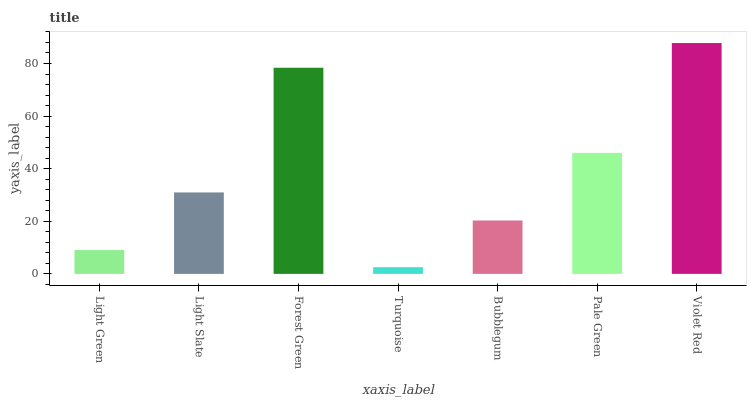Is Turquoise the minimum?
Answer yes or no. Yes. Is Violet Red the maximum?
Answer yes or no. Yes. Is Light Slate the minimum?
Answer yes or no. No. Is Light Slate the maximum?
Answer yes or no. No. Is Light Slate greater than Light Green?
Answer yes or no. Yes. Is Light Green less than Light Slate?
Answer yes or no. Yes. Is Light Green greater than Light Slate?
Answer yes or no. No. Is Light Slate less than Light Green?
Answer yes or no. No. Is Light Slate the high median?
Answer yes or no. Yes. Is Light Slate the low median?
Answer yes or no. Yes. Is Bubblegum the high median?
Answer yes or no. No. Is Pale Green the low median?
Answer yes or no. No. 